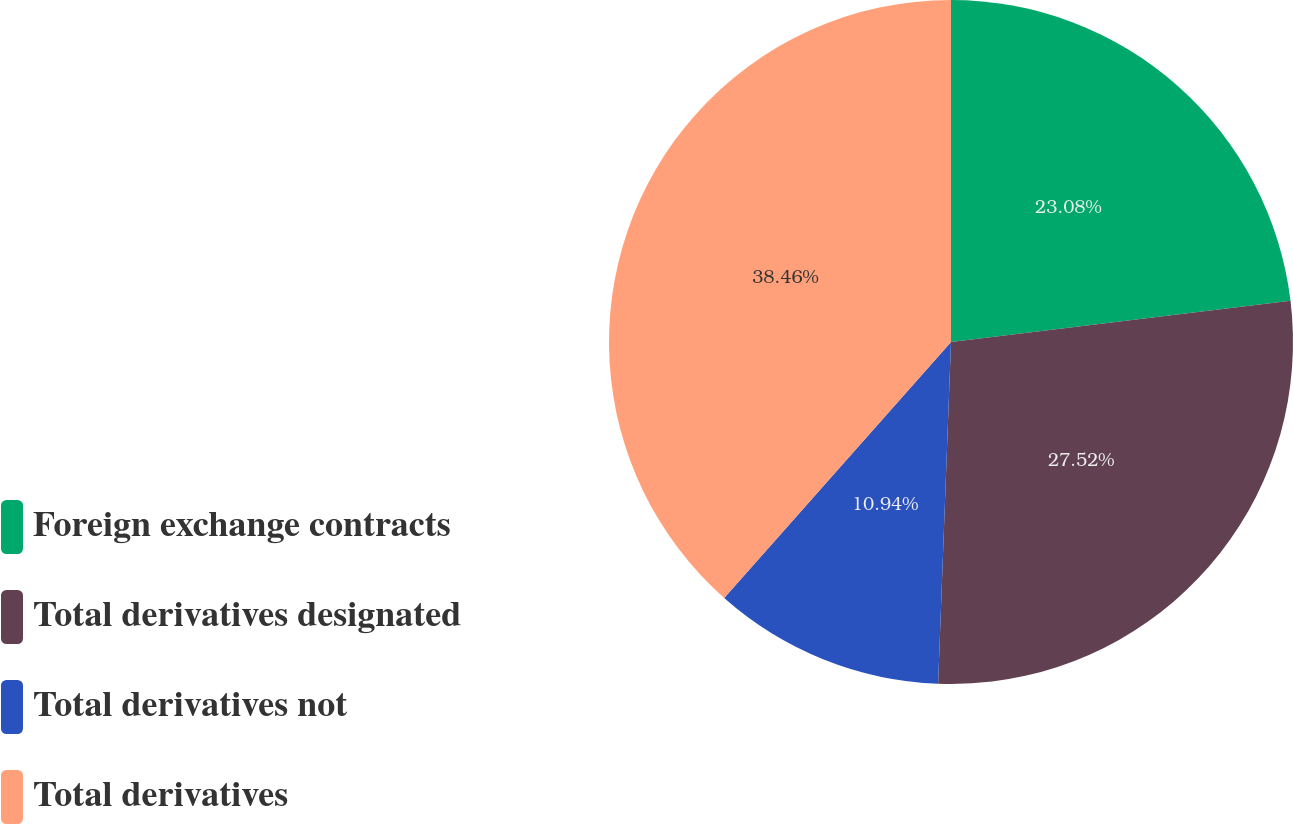Convert chart. <chart><loc_0><loc_0><loc_500><loc_500><pie_chart><fcel>Foreign exchange contracts<fcel>Total derivatives designated<fcel>Total derivatives not<fcel>Total derivatives<nl><fcel>23.08%<fcel>27.52%<fcel>10.94%<fcel>38.46%<nl></chart> 